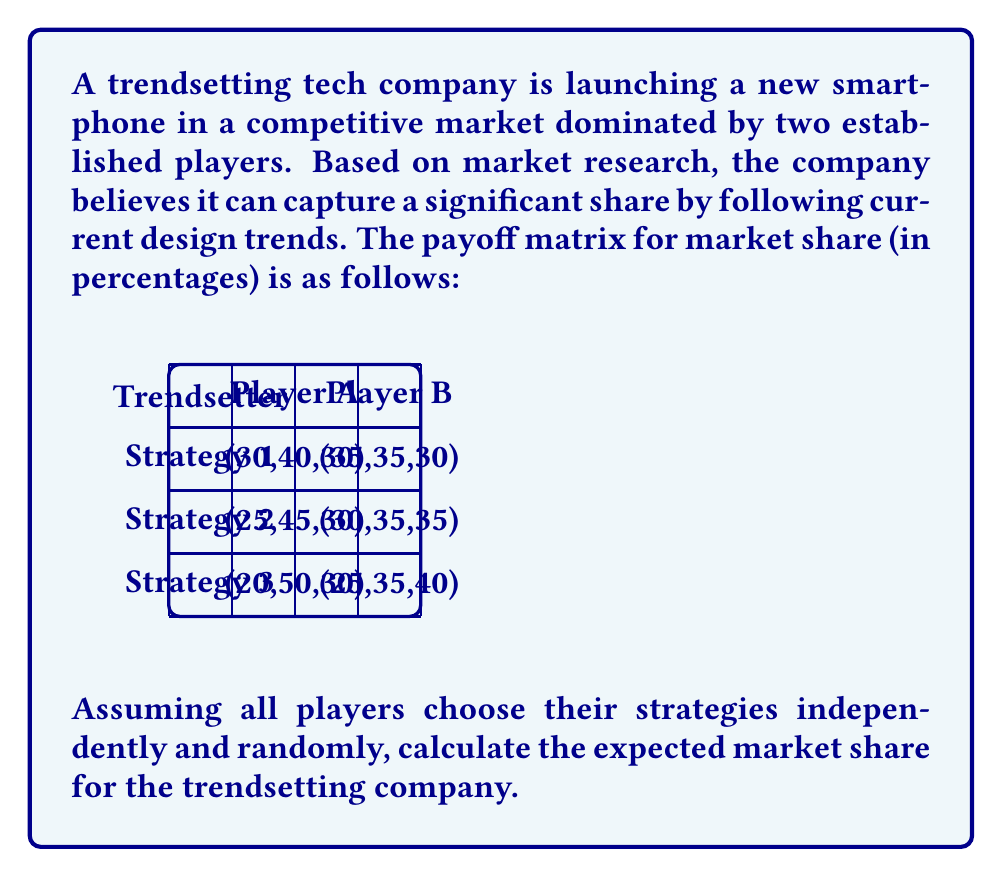Can you answer this question? To solve this problem, we'll use the concept of mixed strategy Nash equilibrium from game theory. Since the players choose their strategies independently and randomly, we need to calculate the expected value of the trendsetting company's market share.

Step 1: Calculate the probability of each strategy combination.
There are 6 possible strategy combinations (3 for Trendsetter × 2 for competitors). The probability of each combination is $\frac{1}{6}$.

Step 2: Calculate the expected market share for each strategy combination.
- (Strategy 1, Player A): $30\% \times \frac{1}{6} = 5\%$
- (Strategy 1, Player B): $35\% \times \frac{1}{6} = 5.83\%$
- (Strategy 2, Player A): $25\% \times \frac{1}{6} = 4.17\%$
- (Strategy 2, Player B): $30\% \times \frac{1}{6} = 5\%$
- (Strategy 3, Player A): $20\% \times \frac{1}{6} = 3.33\%$
- (Strategy 3, Player B): $25\% \times \frac{1}{6} = 4.17\%$

Step 3: Sum up all the expected values to get the total expected market share.
$$E[\text{Market Share}] = 5\% + 5.83\% + 4.17\% + 5\% + 3.33\% + 4.17\% = 27.5\%$$

Therefore, the expected market share for the trendsetting company is 27.5%.
Answer: 27.5% 